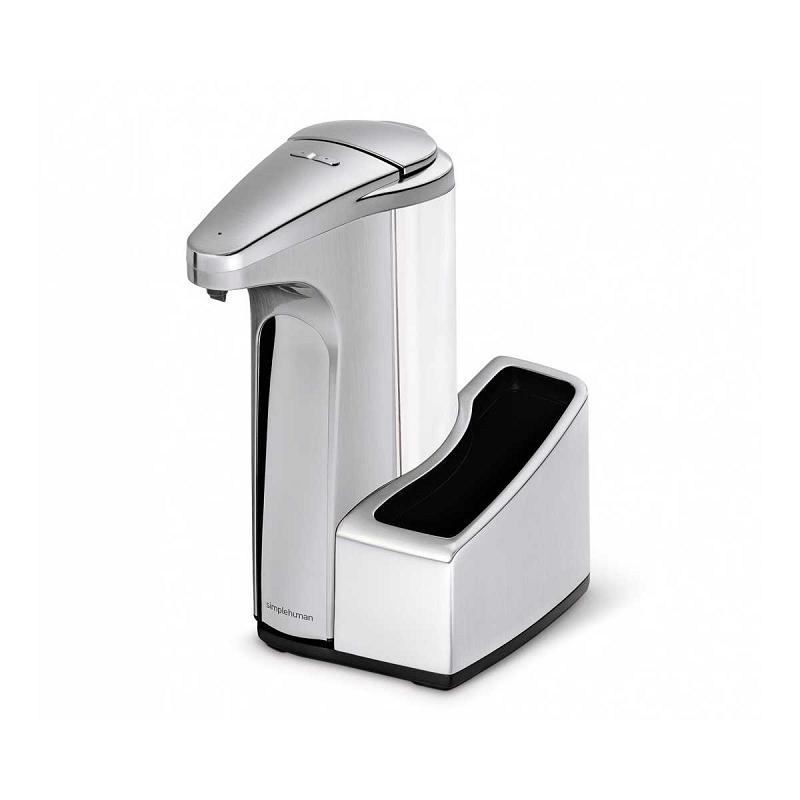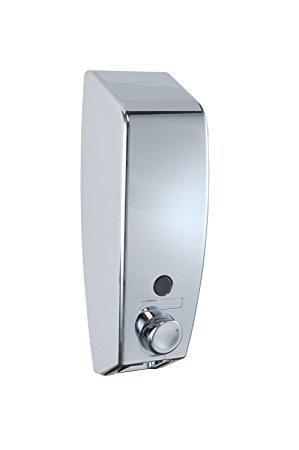The first image is the image on the left, the second image is the image on the right. Analyze the images presented: Is the assertion "There is one round soap dispenser with the spout pointing to the left." valid? Answer yes or no. No. The first image is the image on the left, the second image is the image on the right. For the images shown, is this caption "There is a silver dispenser with three nozzles in the right image." true? Answer yes or no. No. 